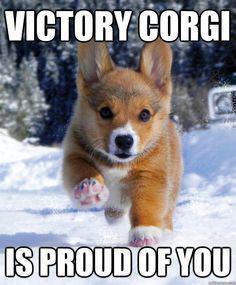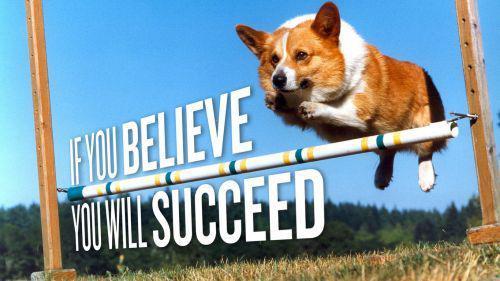The first image is the image on the left, the second image is the image on the right. Examine the images to the left and right. Is the description "There is 1 or more corgi's showing it's tongue." accurate? Answer yes or no. No. 